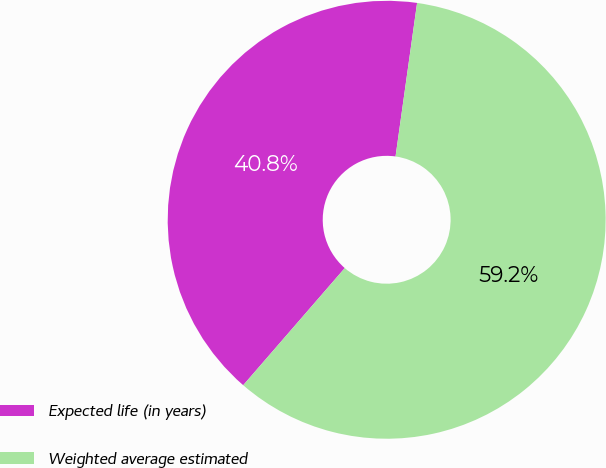<chart> <loc_0><loc_0><loc_500><loc_500><pie_chart><fcel>Expected life (in years)<fcel>Weighted average estimated<nl><fcel>40.85%<fcel>59.15%<nl></chart> 